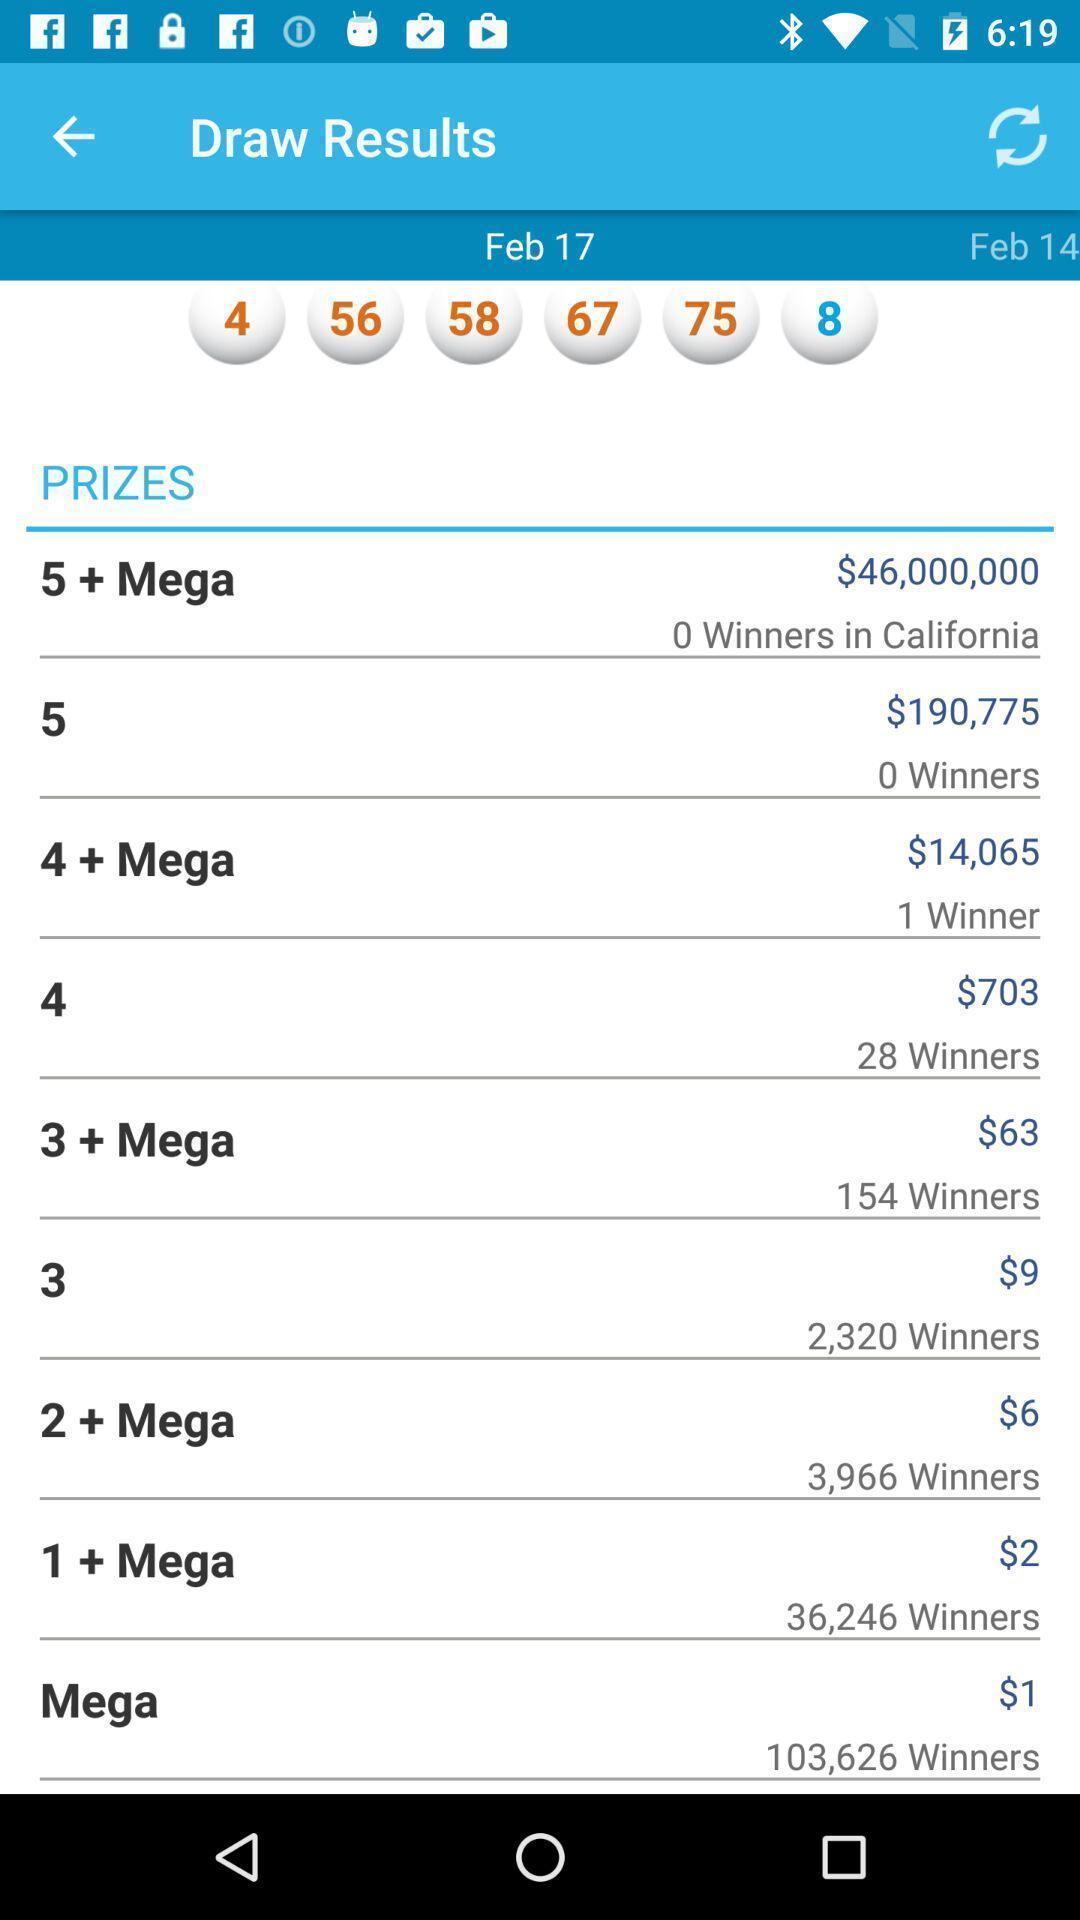Provide a detailed account of this screenshot. Screen shows details. 